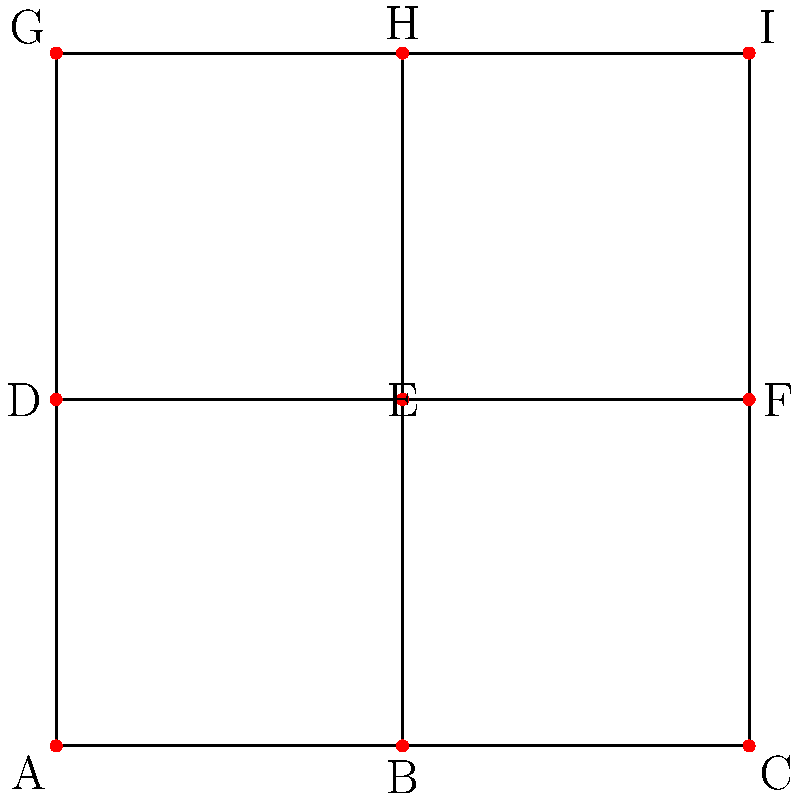In a 3x3 grid neighborhood represented by the graph above, where each intersection is a potential location for a fire hydrant, what is the minimum number of fire hydrants needed to ensure that every intersection is either covered by a hydrant or adjacent to an intersection with a hydrant? Assume a hydrant can cover its own intersection and all adjacent intersections. To solve this problem, we need to find the minimum dominating set of the graph. A dominating set is a subset of vertices such that every vertex in the graph is either in the set or adjacent to a vertex in the set. Here's how we can approach this:

1. First, observe that placing a hydrant at the center (E) covers 5 intersections: E and its four adjacent intersections (B, D, F, H).

2. After placing a hydrant at E, we still need to cover the four corner intersections (A, C, G, I).

3. We can cover these remaining intersections with two more hydrants. There are multiple ways to do this, for example:
   - Place hydrants at A and I
   - Place hydrants at C and G

4. This gives us a total of 3 hydrants (E, A, I) or (E, C, G) that cover all 9 intersections.

5. We can prove this is minimal:
   - We can't use just 1 hydrant, as no single intersection is adjacent to all others.
   - We can't use just 2 hydrants, as the maximum number of intersections covered by 2 hydrants is 8 (if placed at opposite corners).

Therefore, the minimum number of fire hydrants needed is 3.
Answer: 3 